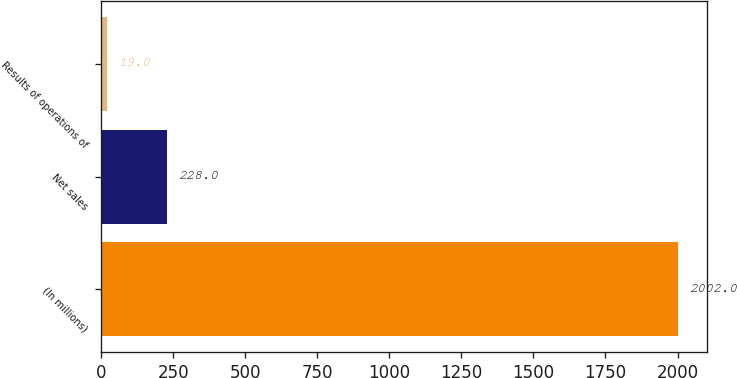<chart> <loc_0><loc_0><loc_500><loc_500><bar_chart><fcel>(In millions)<fcel>Net sales<fcel>Results of operations of<nl><fcel>2002<fcel>228<fcel>19<nl></chart> 